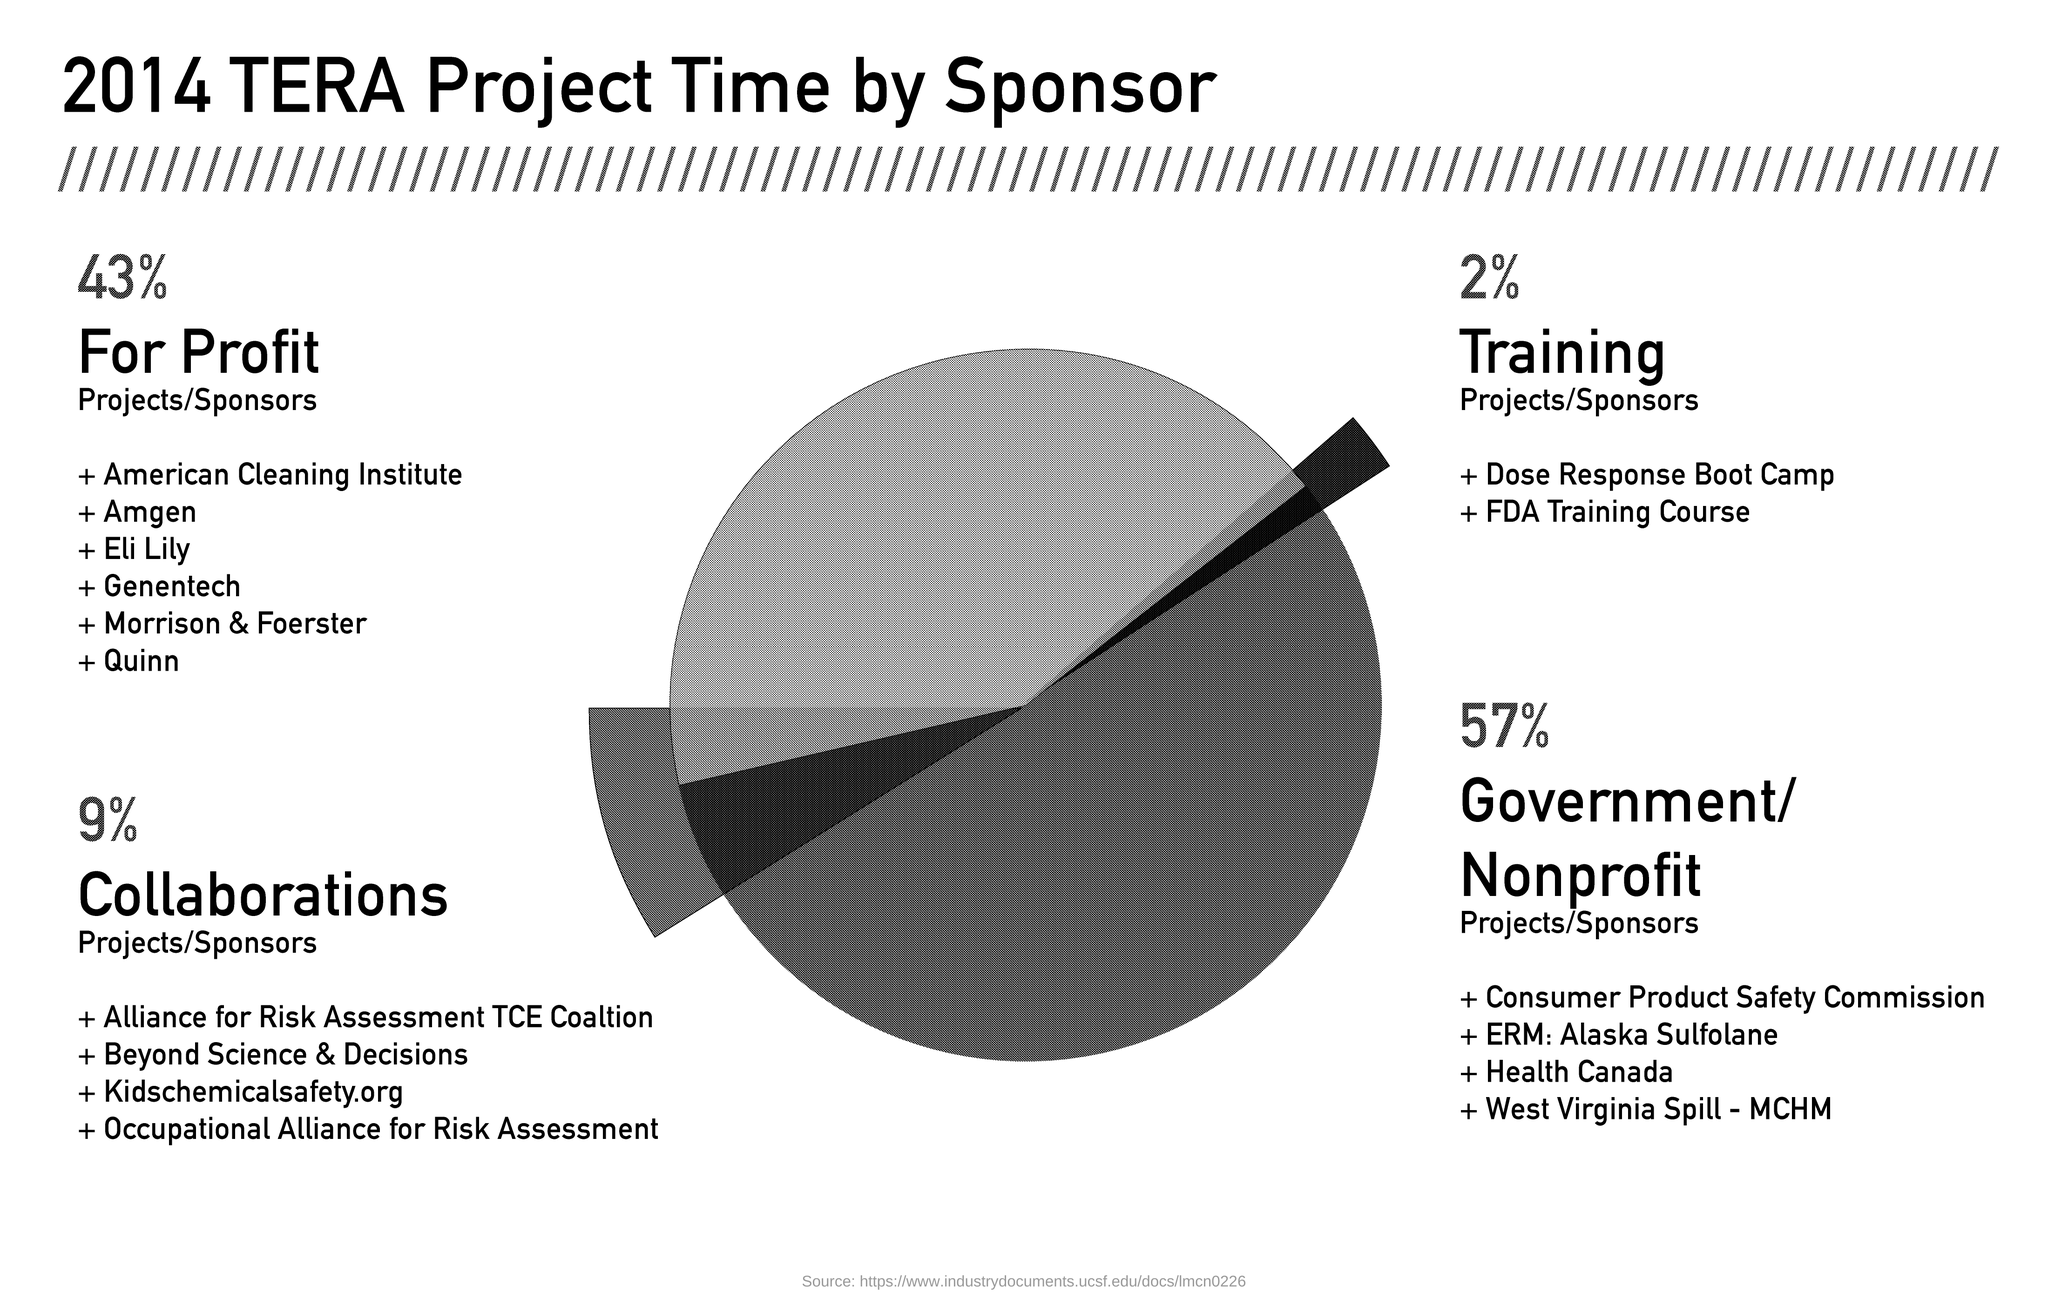List a handful of essential elements in this visual. The title of the document is "2014 TERA Project Time by Sponsor. 